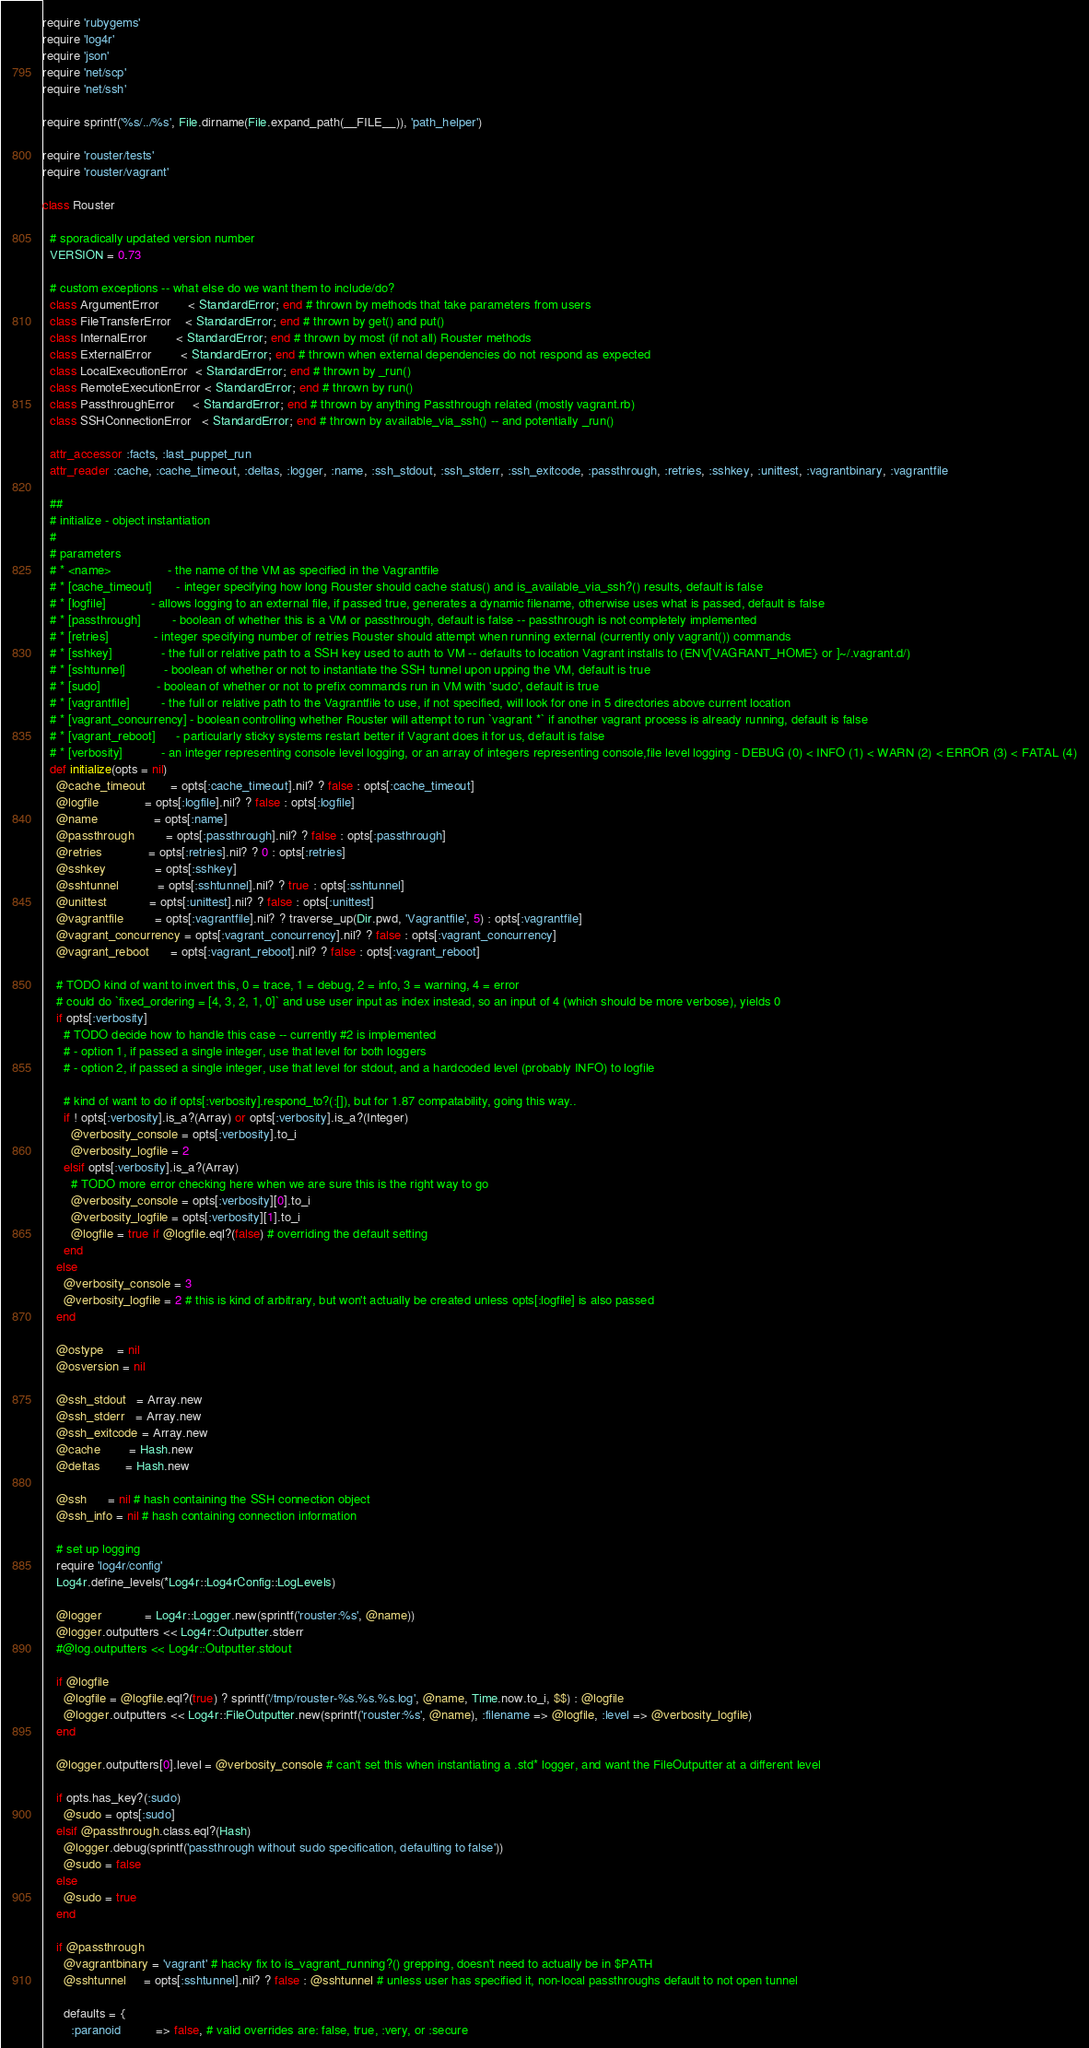Convert code to text. <code><loc_0><loc_0><loc_500><loc_500><_Ruby_>require 'rubygems'
require 'log4r'
require 'json'
require 'net/scp'
require 'net/ssh'

require sprintf('%s/../%s', File.dirname(File.expand_path(__FILE__)), 'path_helper')

require 'rouster/tests'
require 'rouster/vagrant'

class Rouster

  # sporadically updated version number
  VERSION = 0.73

  # custom exceptions -- what else do we want them to include/do?
  class ArgumentError        < StandardError; end # thrown by methods that take parameters from users
  class FileTransferError    < StandardError; end # thrown by get() and put()
  class InternalError        < StandardError; end # thrown by most (if not all) Rouster methods
  class ExternalError        < StandardError; end # thrown when external dependencies do not respond as expected
  class LocalExecutionError  < StandardError; end # thrown by _run()
  class RemoteExecutionError < StandardError; end # thrown by run()
  class PassthroughError     < StandardError; end # thrown by anything Passthrough related (mostly vagrant.rb)
  class SSHConnectionError   < StandardError; end # thrown by available_via_ssh() -- and potentially _run()

  attr_accessor :facts, :last_puppet_run
  attr_reader :cache, :cache_timeout, :deltas, :logger, :name, :ssh_stdout, :ssh_stderr, :ssh_exitcode, :passthrough, :retries, :sshkey, :unittest, :vagrantbinary, :vagrantfile

  ##
  # initialize - object instantiation
  #
  # parameters
  # * <name>                - the name of the VM as specified in the Vagrantfile
  # * [cache_timeout]       - integer specifying how long Rouster should cache status() and is_available_via_ssh?() results, default is false
  # * [logfile]             - allows logging to an external file, if passed true, generates a dynamic filename, otherwise uses what is passed, default is false
  # * [passthrough]         - boolean of whether this is a VM or passthrough, default is false -- passthrough is not completely implemented
  # * [retries]             - integer specifying number of retries Rouster should attempt when running external (currently only vagrant()) commands
  # * [sshkey]              - the full or relative path to a SSH key used to auth to VM -- defaults to location Vagrant installs to (ENV[VAGRANT_HOME} or ]~/.vagrant.d/)
  # * [sshtunnel]           - boolean of whether or not to instantiate the SSH tunnel upon upping the VM, default is true
  # * [sudo]                - boolean of whether or not to prefix commands run in VM with 'sudo', default is true
  # * [vagrantfile]         - the full or relative path to the Vagrantfile to use, if not specified, will look for one in 5 directories above current location
  # * [vagrant_concurrency] - boolean controlling whether Rouster will attempt to run `vagrant *` if another vagrant process is already running, default is false
  # * [vagrant_reboot]      - particularly sticky systems restart better if Vagrant does it for us, default is false
  # * [verbosity]           - an integer representing console level logging, or an array of integers representing console,file level logging - DEBUG (0) < INFO (1) < WARN (2) < ERROR (3) < FATAL (4)
  def initialize(opts = nil)
    @cache_timeout       = opts[:cache_timeout].nil? ? false : opts[:cache_timeout]
    @logfile             = opts[:logfile].nil? ? false : opts[:logfile]
    @name                = opts[:name]
    @passthrough         = opts[:passthrough].nil? ? false : opts[:passthrough]
    @retries             = opts[:retries].nil? ? 0 : opts[:retries]
    @sshkey              = opts[:sshkey]
    @sshtunnel           = opts[:sshtunnel].nil? ? true : opts[:sshtunnel]
    @unittest            = opts[:unittest].nil? ? false : opts[:unittest]
    @vagrantfile         = opts[:vagrantfile].nil? ? traverse_up(Dir.pwd, 'Vagrantfile', 5) : opts[:vagrantfile]
    @vagrant_concurrency = opts[:vagrant_concurrency].nil? ? false : opts[:vagrant_concurrency]
    @vagrant_reboot      = opts[:vagrant_reboot].nil? ? false : opts[:vagrant_reboot]

    # TODO kind of want to invert this, 0 = trace, 1 = debug, 2 = info, 3 = warning, 4 = error
    # could do `fixed_ordering = [4, 3, 2, 1, 0]` and use user input as index instead, so an input of 4 (which should be more verbose), yields 0
    if opts[:verbosity]
      # TODO decide how to handle this case -- currently #2 is implemented
      # - option 1, if passed a single integer, use that level for both loggers
      # - option 2, if passed a single integer, use that level for stdout, and a hardcoded level (probably INFO) to logfile

      # kind of want to do if opts[:verbosity].respond_to?(:[]), but for 1.87 compatability, going this way..
      if ! opts[:verbosity].is_a?(Array) or opts[:verbosity].is_a?(Integer)
        @verbosity_console = opts[:verbosity].to_i
        @verbosity_logfile = 2
      elsif opts[:verbosity].is_a?(Array)
        # TODO more error checking here when we are sure this is the right way to go
        @verbosity_console = opts[:verbosity][0].to_i
        @verbosity_logfile = opts[:verbosity][1].to_i
        @logfile = true if @logfile.eql?(false) # overriding the default setting
      end
    else
      @verbosity_console = 3
      @verbosity_logfile = 2 # this is kind of arbitrary, but won't actually be created unless opts[:logfile] is also passed
    end

    @ostype    = nil
    @osversion = nil

    @ssh_stdout   = Array.new
    @ssh_stderr   = Array.new
    @ssh_exitcode = Array.new
    @cache        = Hash.new
    @deltas       = Hash.new

    @ssh      = nil # hash containing the SSH connection object
    @ssh_info = nil # hash containing connection information

    # set up logging
    require 'log4r/config'
    Log4r.define_levels(*Log4r::Log4rConfig::LogLevels)

    @logger            = Log4r::Logger.new(sprintf('rouster:%s', @name))
    @logger.outputters << Log4r::Outputter.stderr
    #@log.outputters << Log4r::Outputter.stdout

    if @logfile
      @logfile = @logfile.eql?(true) ? sprintf('/tmp/rouster-%s.%s.%s.log', @name, Time.now.to_i, $$) : @logfile
      @logger.outputters << Log4r::FileOutputter.new(sprintf('rouster:%s', @name), :filename => @logfile, :level => @verbosity_logfile)
    end

    @logger.outputters[0].level = @verbosity_console # can't set this when instantiating a .std* logger, and want the FileOutputter at a different level

    if opts.has_key?(:sudo)
      @sudo = opts[:sudo]
    elsif @passthrough.class.eql?(Hash)
      @logger.debug(sprintf('passthrough without sudo specification, defaulting to false'))
      @sudo = false
    else
      @sudo = true
    end

    if @passthrough
      @vagrantbinary = 'vagrant' # hacky fix to is_vagrant_running?() grepping, doesn't need to actually be in $PATH
      @sshtunnel     = opts[:sshtunnel].nil? ? false : @sshtunnel # unless user has specified it, non-local passthroughs default to not open tunnel

      defaults = {
        :paranoid          => false, # valid overrides are: false, true, :very, or :secure</code> 